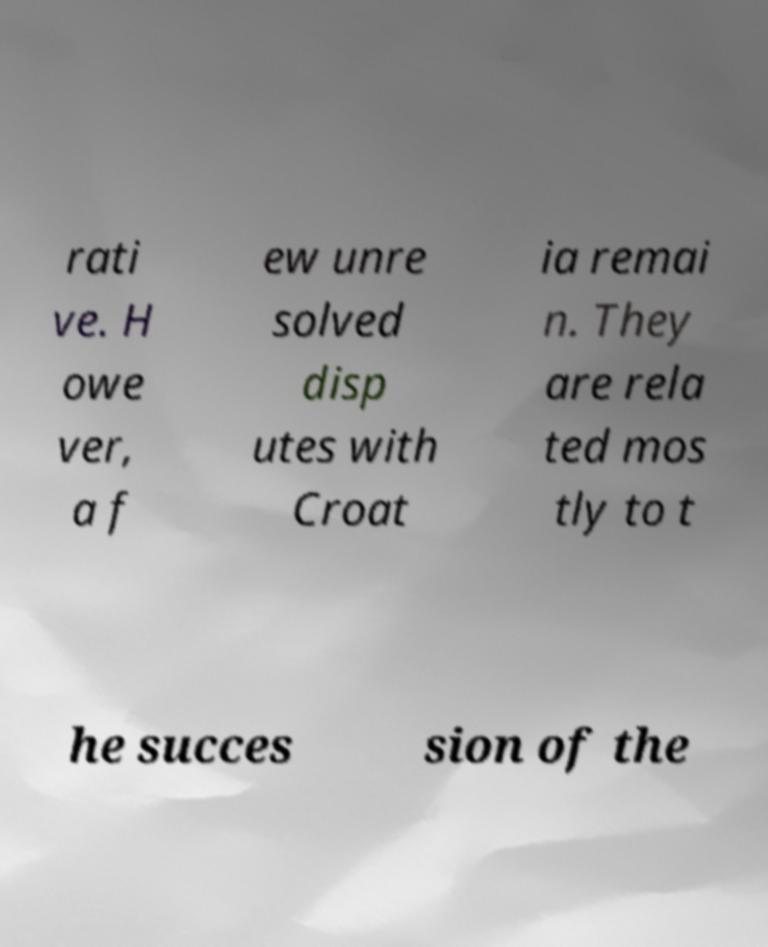There's text embedded in this image that I need extracted. Can you transcribe it verbatim? rati ve. H owe ver, a f ew unre solved disp utes with Croat ia remai n. They are rela ted mos tly to t he succes sion of the 